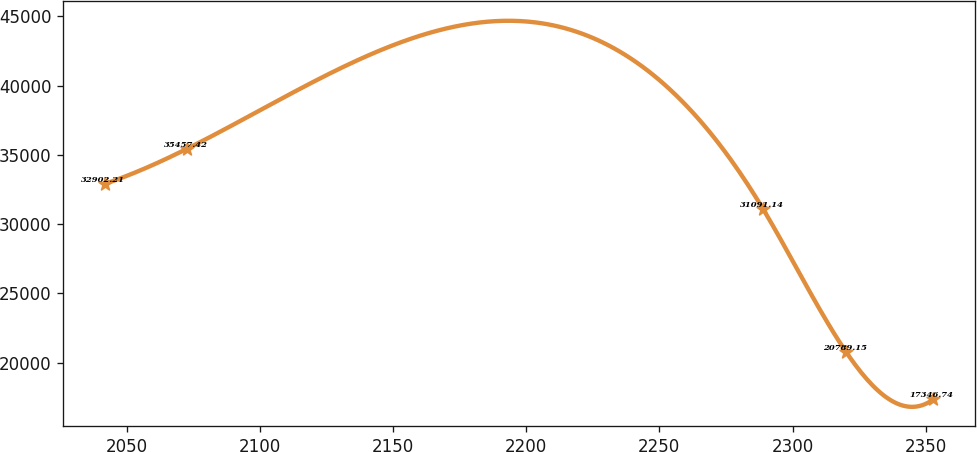<chart> <loc_0><loc_0><loc_500><loc_500><line_chart><ecel><fcel>Unnamed: 1<nl><fcel>2041.7<fcel>32902.2<nl><fcel>2072.81<fcel>35457.4<nl><fcel>2288.95<fcel>31091.1<nl><fcel>2320.06<fcel>20789.2<nl><fcel>2352.83<fcel>17346.7<nl></chart> 